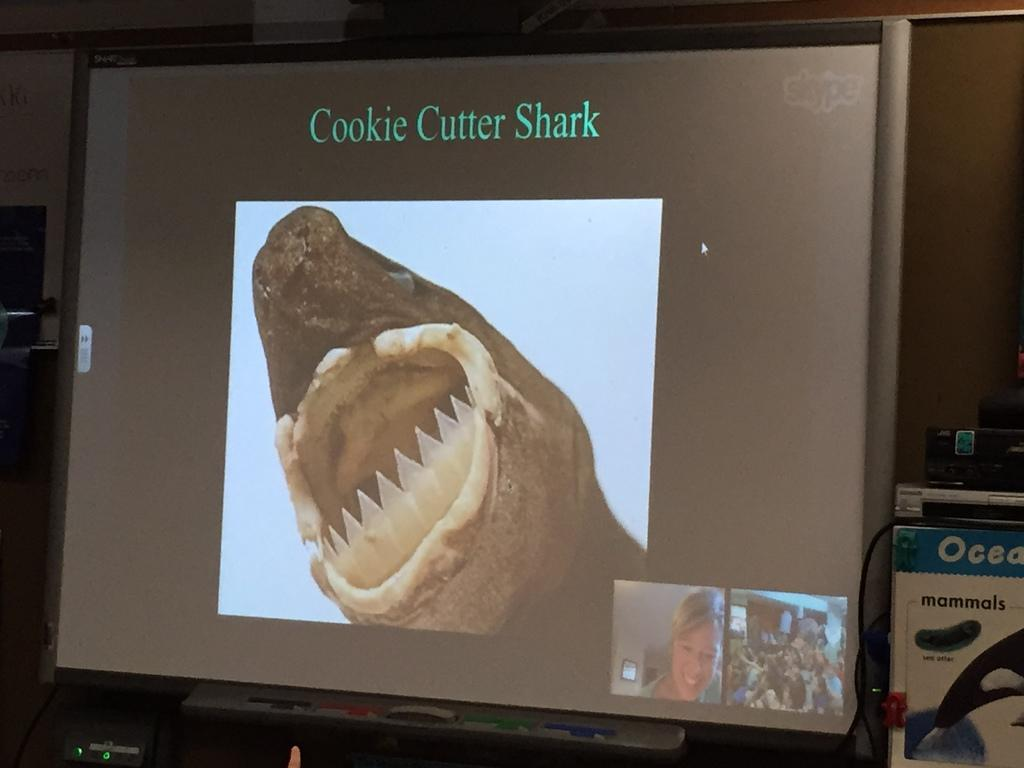<image>
Create a compact narrative representing the image presented. The creature pictured on the monitor is captioned with 'Cookie Cutter Shark'. 